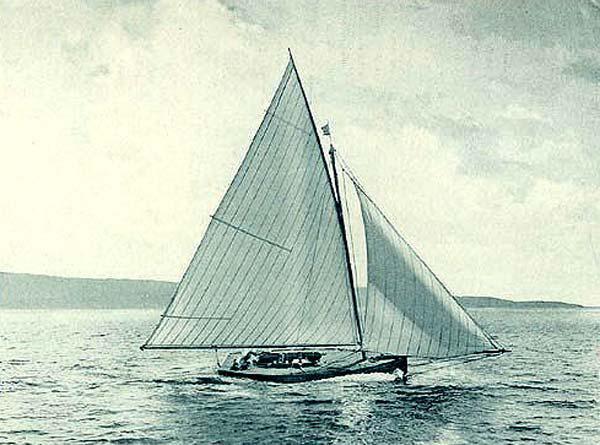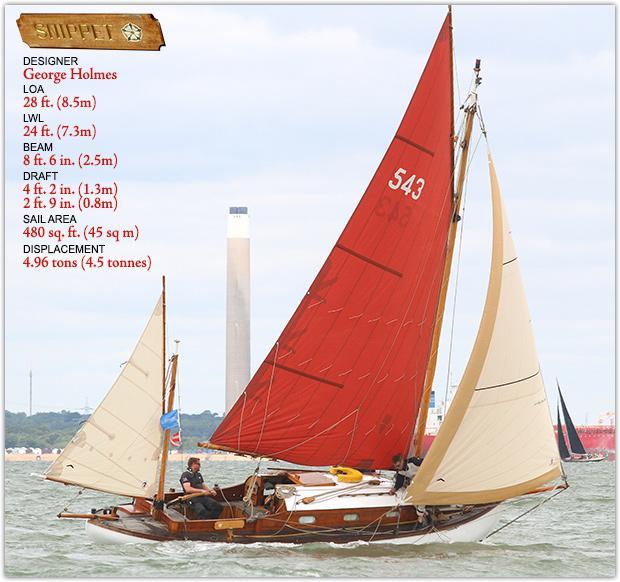The first image is the image on the left, the second image is the image on the right. Given the left and right images, does the statement "The left and right image contains three sailboats with open sails." hold true? Answer yes or no. Yes. The first image is the image on the left, the second image is the image on the right. Given the left and right images, does the statement "Both of the boats have all their sails up." hold true? Answer yes or no. Yes. 